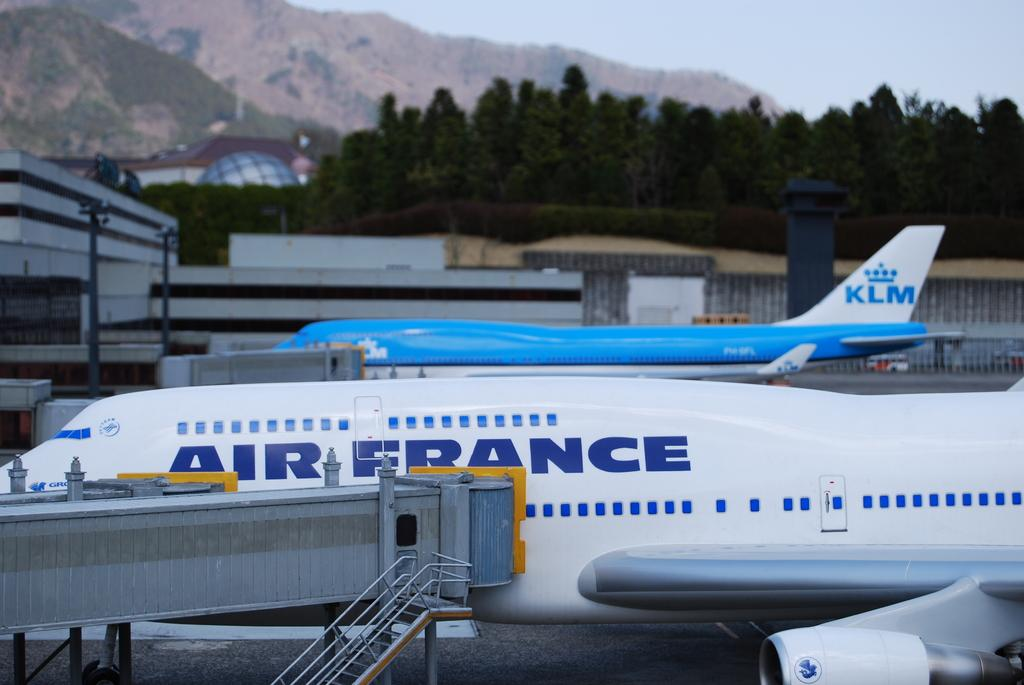Provide a one-sentence caption for the provided image. white air france airplane and blue and white plane with klm on the tail. 